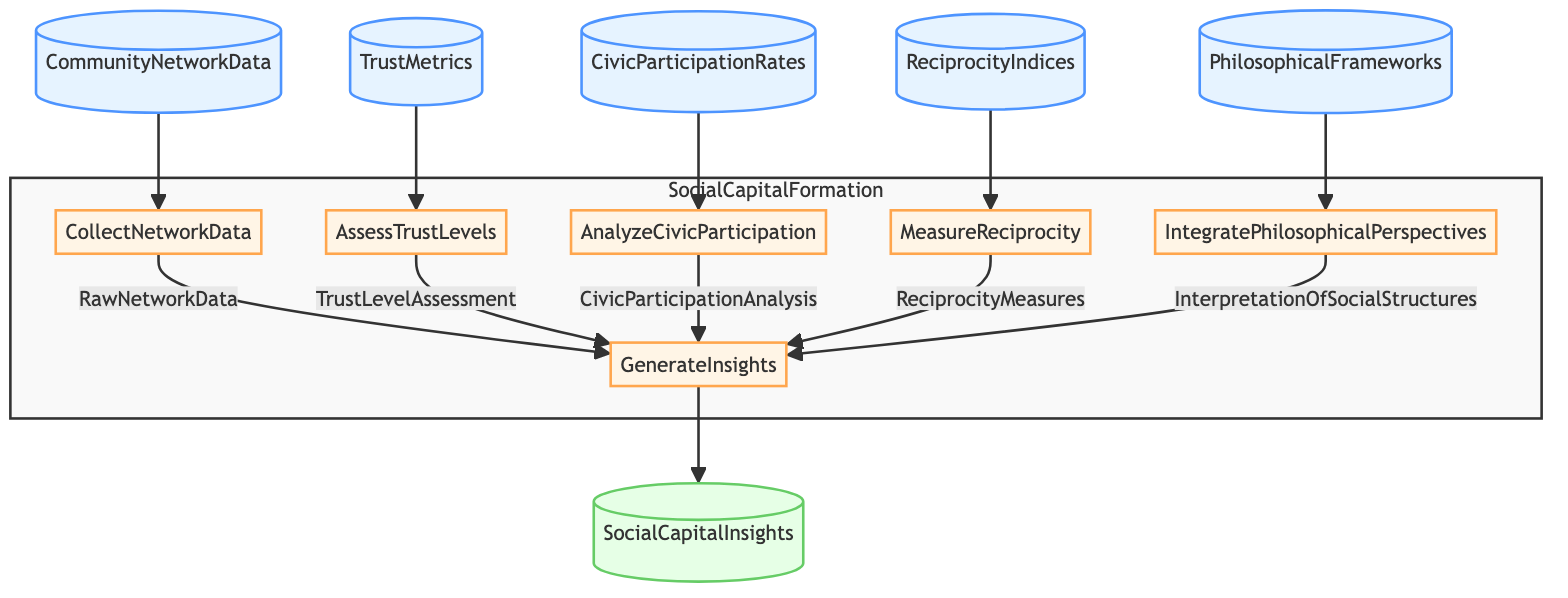What are the inputs of the function in the diagram? The diagram lists five inputs: CommunityNetworkData, TrustMetrics, CivicParticipationRates, ReciprocityIndices, and PhilosophicalFrameworks, which are depicted as nodes connected to their respective steps.
Answer: CommunityNetworkData, TrustMetrics, CivicParticipationRates, ReciprocityIndices, PhilosophicalFrameworks How many steps are there in the process? The diagram outlines six steps: CollectNetworkData, AssessTrustLevels, AnalyzeCivicParticipation, MeasureReciprocity, IntegratePhilosophicalPerspectives, and GenerateInsights, which can be counted directly from the flowchart.
Answer: Six What is the output of the function? The final node in the flowchart indicates that the output of the function is SocialCapitalInsights, clearly shown as the concluding element in the flowchart's flow.
Answer: SocialCapitalInsights Which step uses the output of AssessTrustLevels? The step GenerateInsights receives the output labeled TrustLevelAssessment from AssessTrustLevels, evidenced by the directed edge connecting them in the flowchart.
Answer: GenerateInsights Which input is associated with the step MeasureReciprocity? The input connected to the step MeasureReciprocity is ReciprocityIndices, as indicated by the direct connection leading to that specific step in the diagram.
Answer: ReciprocityIndices What inputs are combined at the GenerateInsights step? The GenerateInsights step amalgamates five inputs: RawNetworkData, TrustLevelAssessment, CivicParticipationAnalysis, ReciprocityMeasures, and InterpretationOfSocialStructures, evidenced by the arrows pointing toward it from those preceding nodes.
Answer: RawNetworkData, TrustLevelAssessment, CivicParticipationAnalysis, ReciprocityMeasures, InterpretationOfSocialStructures Which step integrates philosophical perspectives? The step called IntegratePhilosophicalPerspectives explicitly describes applying philosophical frameworks, connecting directly to its input node PhilosophicalFrameworks.
Answer: IntegratePhilosophicalPerspectives What is the relationship between CollectNetworkData and GenerateInsights steps? CollectNetworkData is a preceding step that provides the output RawNetworkData, which is one of the inputs into the GenerateInsights step, demonstrating a flow of information.
Answer: Preceding How many inputs lead into the step AnalyzeCivicParticipation? There is only one input that leads into AnalyzeCivicParticipation, which is CivicParticipationRates, clearly visible and directly linked to that step in the diagram.
Answer: One What do the colored classes signify in the diagram? The colored classes differentiate between inputs, steps, and output in the flowchart: inputClass for inputs, stepClass for steps, and outputClass for the final output node, as categorized in the diagram.
Answer: Input, step, output 